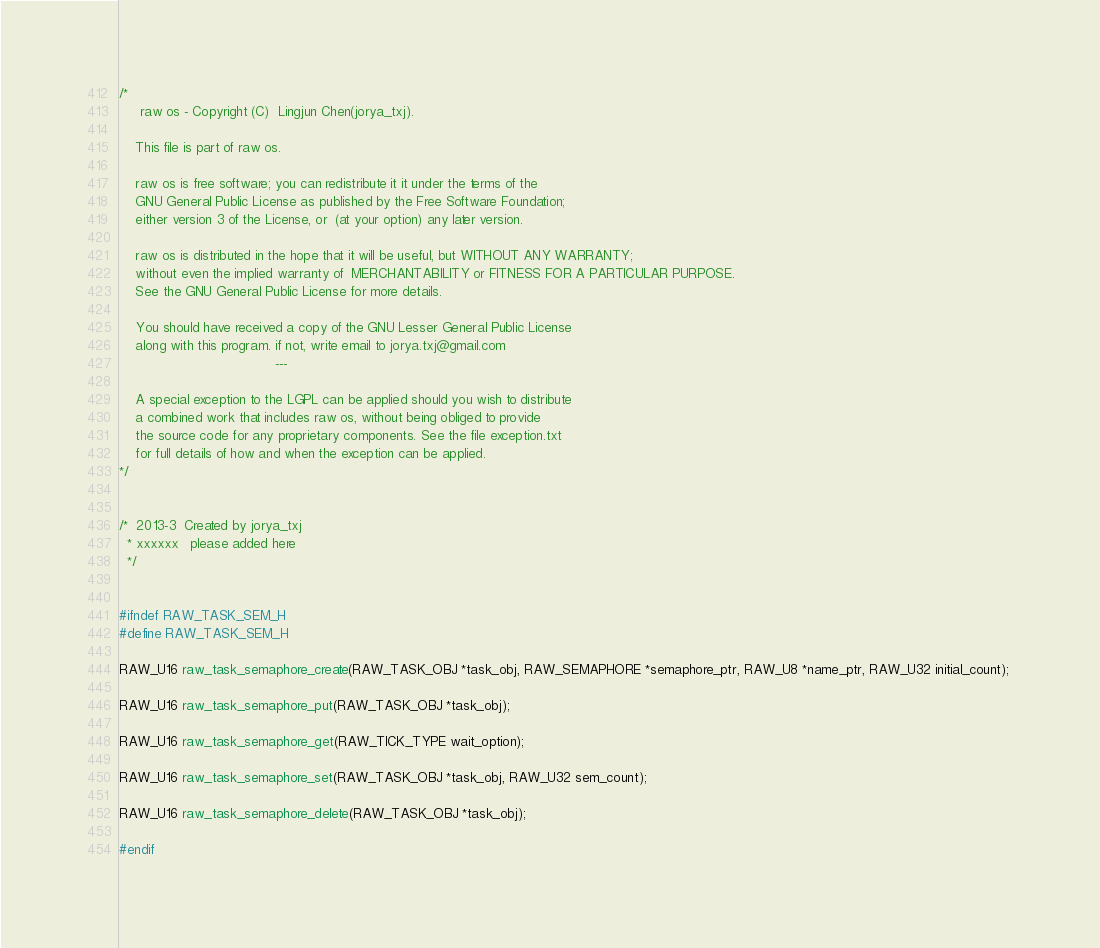Convert code to text. <code><loc_0><loc_0><loc_500><loc_500><_C_>/*
     raw os - Copyright (C)  Lingjun Chen(jorya_txj).

    This file is part of raw os.

    raw os is free software; you can redistribute it it under the terms of the 
    GNU General Public License as published by the Free Software Foundation; 
    either version 3 of the License, or  (at your option) any later version.

    raw os is distributed in the hope that it will be useful, but WITHOUT ANY WARRANTY; 
    without even the implied warranty of  MERCHANTABILITY or FITNESS FOR A PARTICULAR PURPOSE.  
    See the GNU General Public License for more details.

    You should have received a copy of the GNU Lesser General Public License
    along with this program. if not, write email to jorya.txj@gmail.com
                                      ---

    A special exception to the LGPL can be applied should you wish to distribute
    a combined work that includes raw os, without being obliged to provide
    the source code for any proprietary components. See the file exception.txt
    for full details of how and when the exception can be applied.
*/


/* 	2013-3  Created by jorya_txj
  *	xxxxxx   please added here
  */


#ifndef RAW_TASK_SEM_H
#define RAW_TASK_SEM_H

RAW_U16 raw_task_semaphore_create(RAW_TASK_OBJ *task_obj, RAW_SEMAPHORE *semaphore_ptr, RAW_U8 *name_ptr, RAW_U32 initial_count); 

RAW_U16 raw_task_semaphore_put(RAW_TASK_OBJ *task_obj);

RAW_U16 raw_task_semaphore_get(RAW_TICK_TYPE wait_option);

RAW_U16 raw_task_semaphore_set(RAW_TASK_OBJ *task_obj, RAW_U32 sem_count);

RAW_U16 raw_task_semaphore_delete(RAW_TASK_OBJ *task_obj);

#endif


</code> 